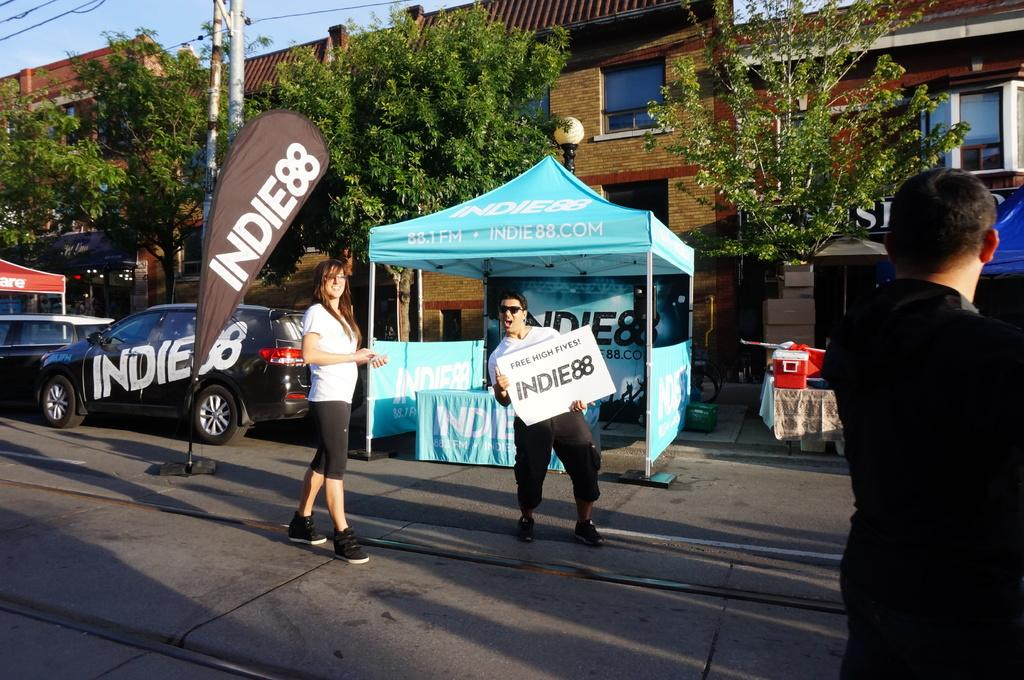How many people are in the image? There are 3 people standing in the image. What is the person at the center holding? The person at the center is holding a card. What type of temporary shelters can be seen in the image? There are tents in the image. What infrastructure elements are present in the image? Electric poles and wires, a light pole, and buildings are visible in the image. What type of transportation is present in the image? There are vehicles in the image. Where is the zoo located in the image? There is no zoo present in the image. What type of ground is visible in the image? The ground is not explicitly mentioned in the image, but it can be inferred that there is some type of ground or surface present. 